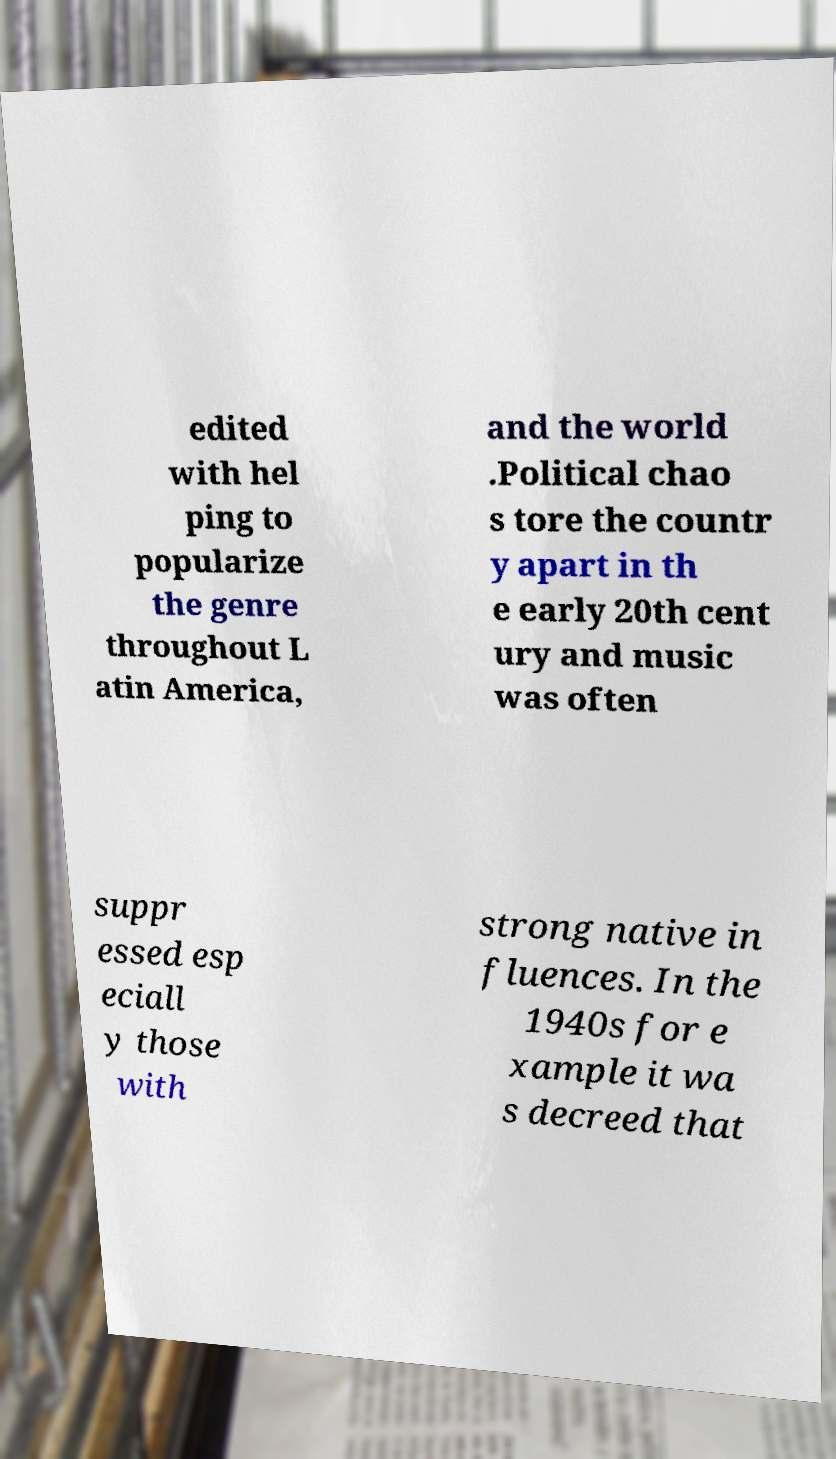Could you assist in decoding the text presented in this image and type it out clearly? edited with hel ping to popularize the genre throughout L atin America, and the world .Political chao s tore the countr y apart in th e early 20th cent ury and music was often suppr essed esp eciall y those with strong native in fluences. In the 1940s for e xample it wa s decreed that 